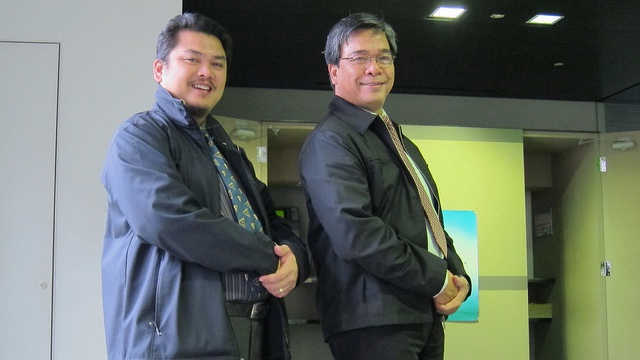Describe the objects in this image and their specific colors. I can see people in darkgray, black, and gray tones, people in darkgray, black, gray, and tan tones, tie in darkgray, teal, gray, black, and blue tones, and tie in darkgray, tan, gray, and olive tones in this image. 